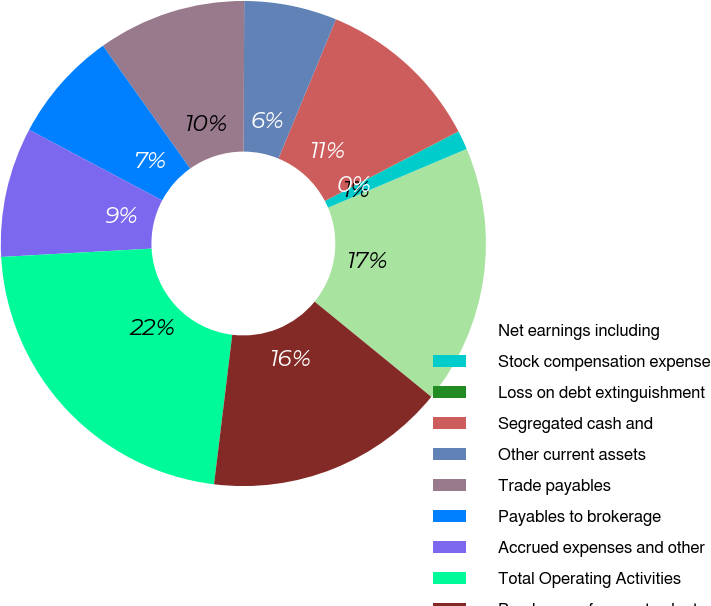Convert chart. <chart><loc_0><loc_0><loc_500><loc_500><pie_chart><fcel>Net earnings including<fcel>Stock compensation expense<fcel>Loss on debt extinguishment<fcel>Segregated cash and<fcel>Other current assets<fcel>Trade payables<fcel>Payables to brokerage<fcel>Accrued expenses and other<fcel>Total Operating Activities<fcel>Purchases of property plant<nl><fcel>17.27%<fcel>1.26%<fcel>0.02%<fcel>11.11%<fcel>6.18%<fcel>9.88%<fcel>7.41%<fcel>8.65%<fcel>22.19%<fcel>16.04%<nl></chart> 